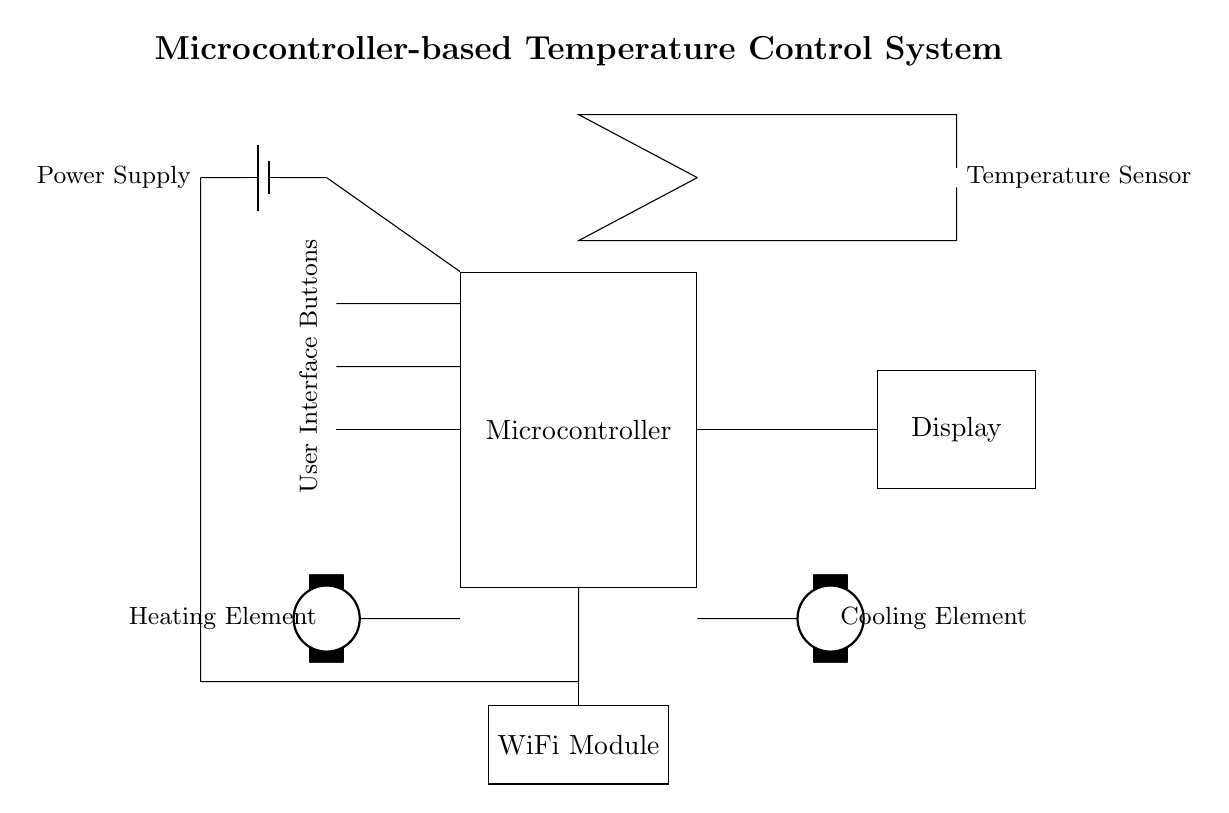What is the main purpose of the microcontroller in this circuit? The microcontroller processes inputs from the temperature sensor and controls both the heating and cooling elements based on predefined logic to maintain the desired temperature.
Answer: Temperature control What type of temperature measurement device is used in this system? The diagram shows a thermistor, which is a type of temperature sensor that changes resistance with temperature.
Answer: Thermistor How many user interface buttons are present? There are three user interface buttons illustrated in the circuit diagram.
Answer: Three What components are used to regulate temperature in this system? The components used are a heating element and a cooling element, which are controlled by the microcontroller based on temperature readings.
Answer: Heating element and cooling element Which module allows for wireless communication in this temperature control system? The WiFi module facilitates wireless communication, enabling remote control and monitoring of the thermostat from a mobile device or computer.
Answer: WiFi module Describe the power supply's role in this circuit. The power supply provides the necessary voltage to the microcontroller and all other components in the circuit, ensuring they function properly.
Answer: Voltage supply What is the connection between the temperature sensor and the microcontroller? The temperature sensor is directly connected to the microcontroller, allowing it to send temperature readings for processing and decision-making.
Answer: Direct connection 